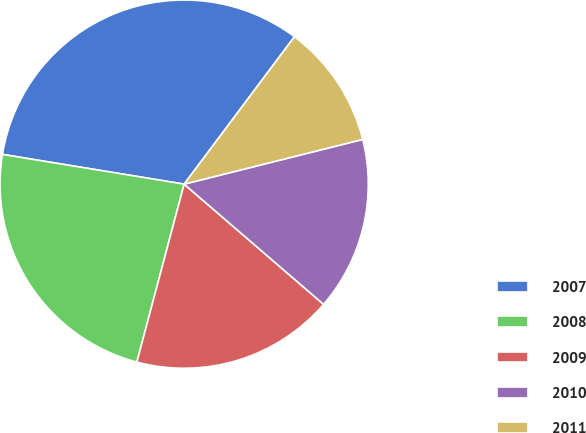Convert chart to OTSL. <chart><loc_0><loc_0><loc_500><loc_500><pie_chart><fcel>2007<fcel>2008<fcel>2009<fcel>2010<fcel>2011<nl><fcel>32.64%<fcel>23.45%<fcel>17.81%<fcel>15.23%<fcel>10.87%<nl></chart> 